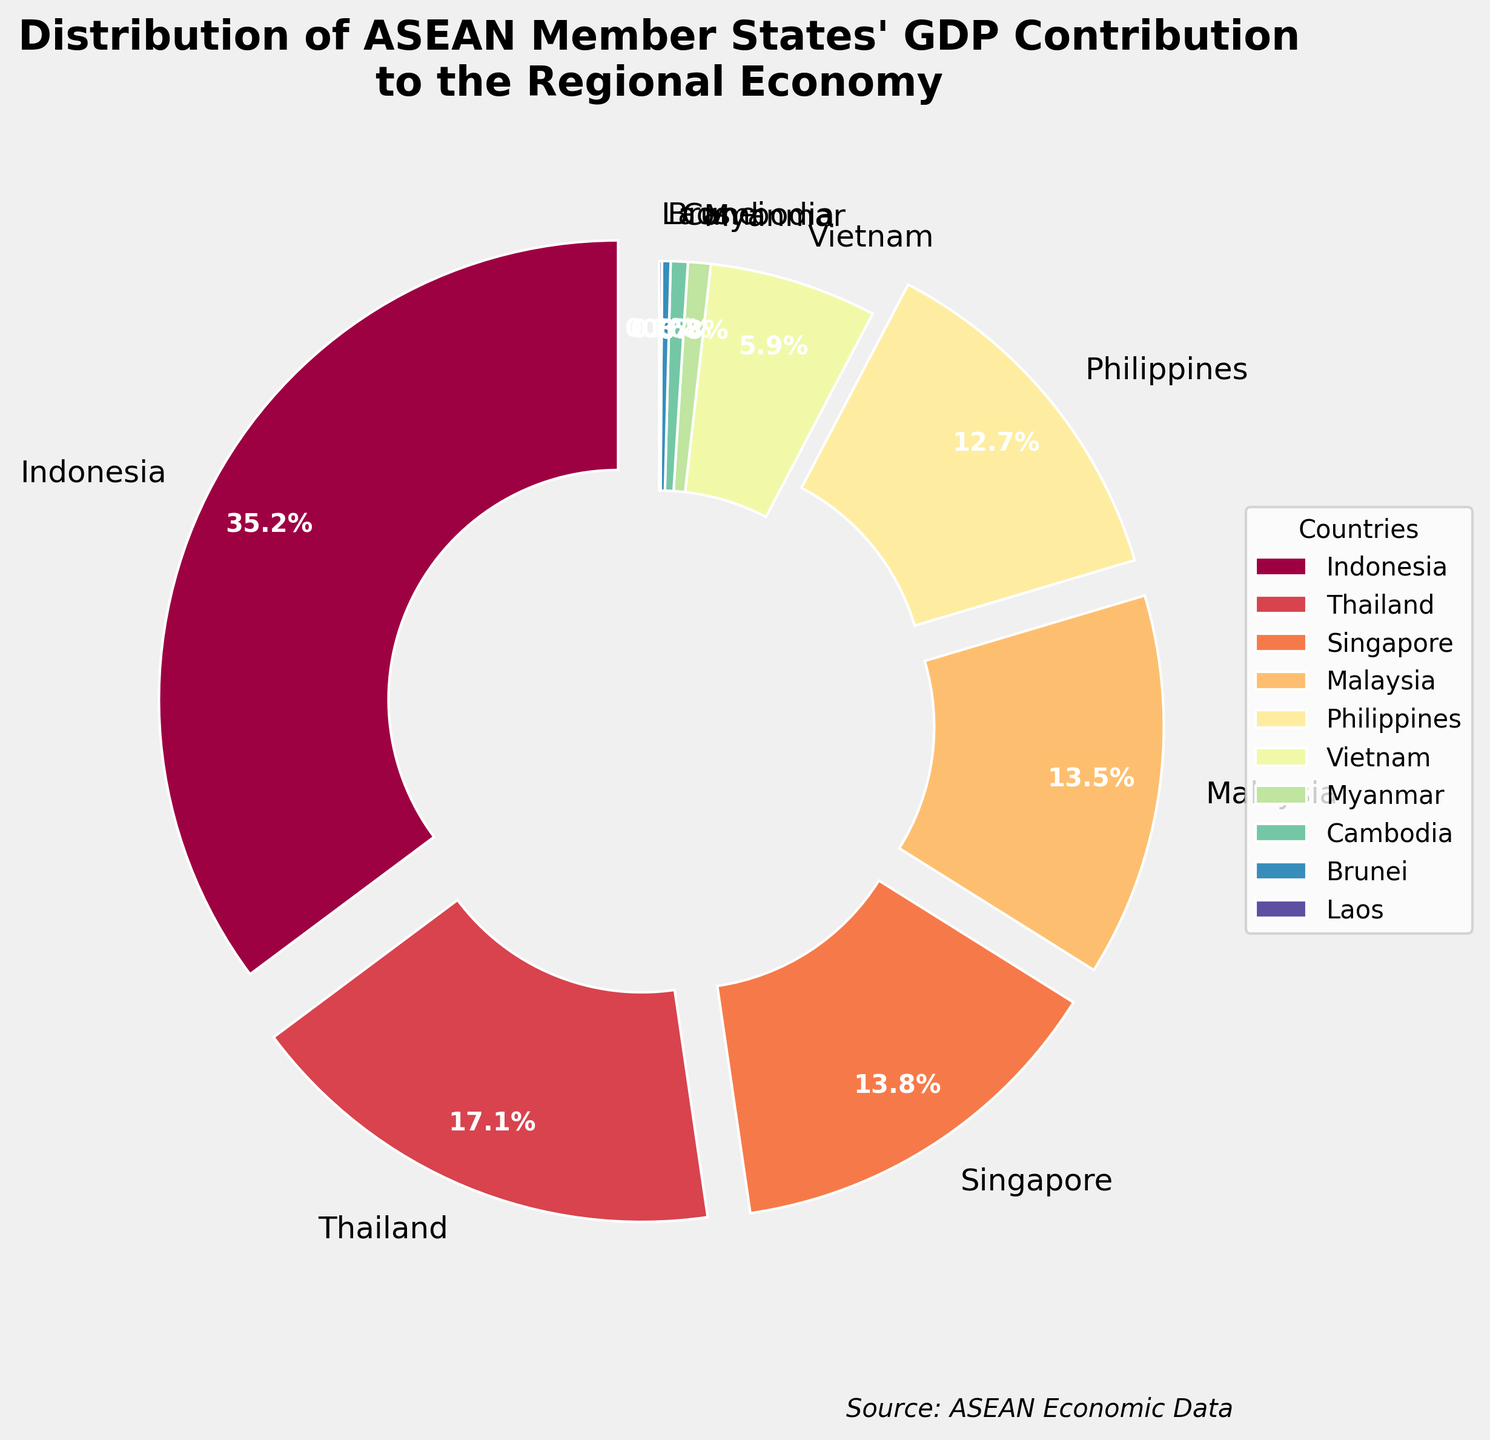Which country contributes the most to ASEAN's GDP? The largest wedge in the pie chart, specified by its label, indicates Indonesia contributes the most at 35.2%.
Answer: Indonesia Which country has a GDP contribution close to Malaysia but slightly higher? Comparing the wedges, Singapore's contribution of 13.8% is close to and slightly higher than Malaysia's 13.5%.
Answer: Singapore What is the combined GDP contribution of the two countries with the lowest percentages? Cambodia and Laos have the lowest wedges, contributing 0.6% and 0.1% respectively. Summing them gives 0.6% + 0.1% = 0.7%.
Answer: 0.7% How does the GDP contribution of Thailand compare to that of the Philippines? The visual comparison shows that Thailand's wedge is larger than the Philippines', contributing 17.1%, whereas the Philippines contributes 12.7%.
Answer: Thailand's contribution is larger What is the total GDP contribution of the countries contributing more than 10% each? The countries are Indonesia, Thailand, Singapore, Malaysia, and the Philippines. Summing their contributions: 35.2% + 17.1% + 13.8% + 13.5% + 12.7% = 92.3%.
Answer: 92.3% Which two countries combined have a GDP contribution closest to Vietnam's 5.9%? Myanmar (0.8%) and Cambodia (0.6%) together contribute 1.4%, which is closer to Brunei (0.3%) and Laos (0.1%) together at 0.4%. Hence, Myanmar and Cambodia are the closest to Vietnam's contribution.
Answer: Myanmar and Cambodia What is the difference in GDP contribution between the country with the highest and the country with the lowest contributions? Indonesia contributes the highest at 35.2%, while Laos contributes the lowest at 0.1%. The difference is 35.2% - 0.1% = 35.1%.
Answer: 35.1% What is the sum of GDP contributions of the countries with guidelines exploded wedges? The exploded wedges in the chart represent Indonesia, Thailand, Singapore, Malaysia, and the Philippines, which are the countries contributing more than 10%. Summing their contributions gives 35.2% + 17.1% + 13.8% + 13.5% + 12.7% = 92.3%.
Answer: 92.3% Which country contributes the least, and what is its percentage? The smallest wedge represents Laos, which contributes only 0.1% to ASEAN's GDP.
Answer: Laos, 0.1% How much more does Indonesia contribute to ASEAN's GDP compared to Vietnam? Indonesia's contribution is 35.2%, and Vietnam's is 5.9%. The difference is 35.2% - 5.9% = 29.3%.
Answer: 29.3% 